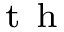<formula> <loc_0><loc_0><loc_500><loc_500>^ { t h }</formula> 